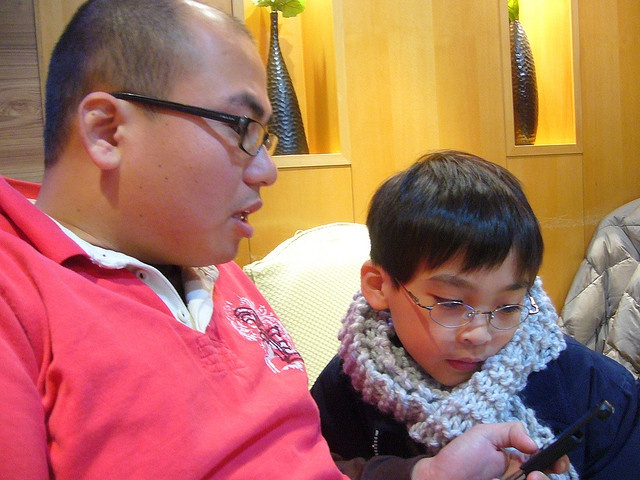Describe the objects in this image and their specific colors. I can see people in purple, salmon, and brown tones, people in purple, black, brown, navy, and gray tones, couch in purple, ivory, khaki, lightpink, and salmon tones, couch in purple, darkgray, gray, and lightgray tones, and vase in purple, gray, olive, maroon, and orange tones in this image. 